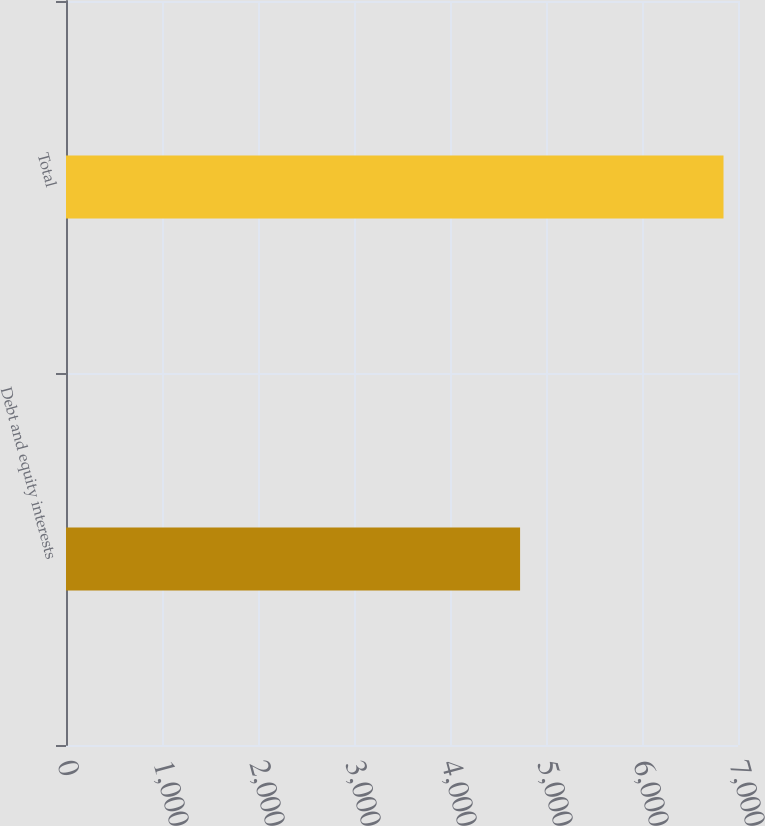<chart> <loc_0><loc_0><loc_500><loc_500><bar_chart><fcel>Debt and equity interests<fcel>Total<nl><fcel>4730<fcel>6849<nl></chart> 